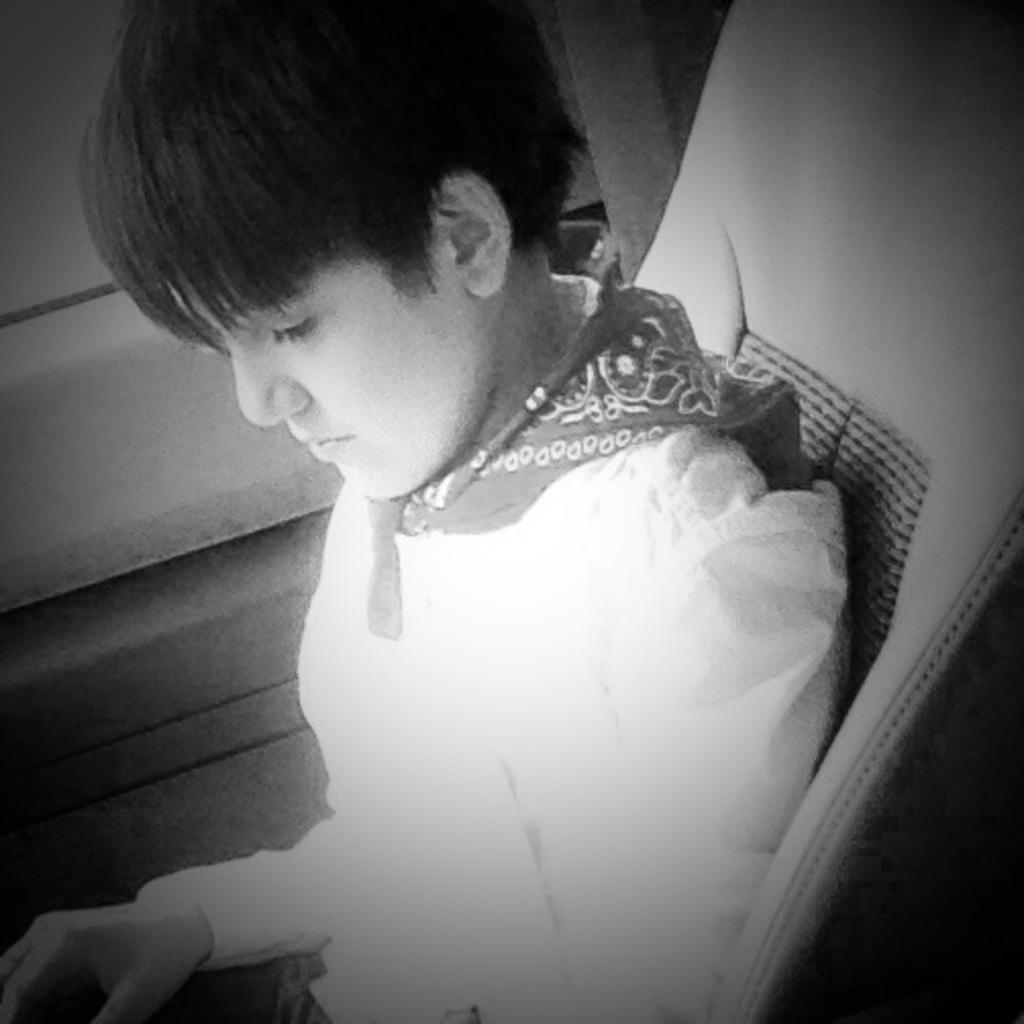What is the color scheme of the image? The image is black and white. What is the main subject of the image? There is a picture of a boy in the image. What is the boy doing in the image? The boy is sitting on a chair. What can be seen in the background of the image? There is a door visible in the background of the image. What type of boat is visible in the image? There is no boat present in the image; it is a black and white picture of a boy sitting on a chair with a door visible in the background. What kind of flowers can be seen in the image? There are no flowers present in the image. 